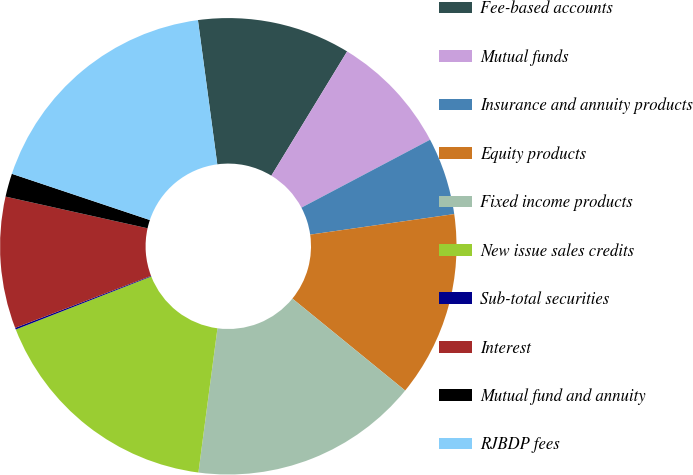Convert chart to OTSL. <chart><loc_0><loc_0><loc_500><loc_500><pie_chart><fcel>Fee-based accounts<fcel>Mutual funds<fcel>Insurance and annuity products<fcel>Equity products<fcel>Fixed income products<fcel>New issue sales credits<fcel>Sub-total securities<fcel>Interest<fcel>Mutual fund and annuity<fcel>RJBDP fees<nl><fcel>10.84%<fcel>8.55%<fcel>5.48%<fcel>13.14%<fcel>16.2%<fcel>16.97%<fcel>0.12%<fcel>9.31%<fcel>1.65%<fcel>17.73%<nl></chart> 